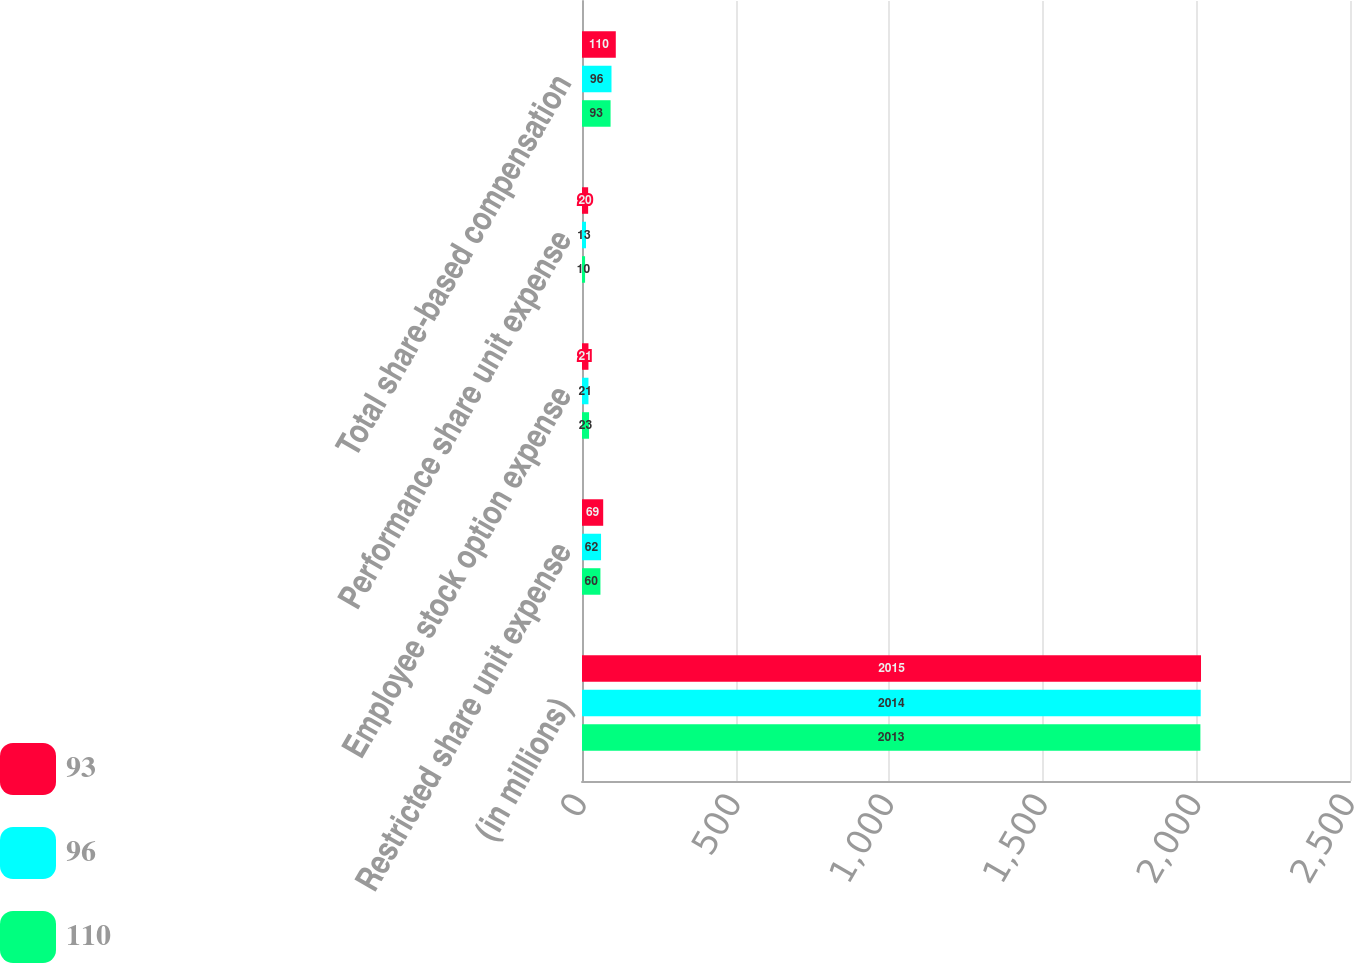Convert chart. <chart><loc_0><loc_0><loc_500><loc_500><stacked_bar_chart><ecel><fcel>(in millions)<fcel>Restricted share unit expense<fcel>Employee stock option expense<fcel>Performance share unit expense<fcel>Total share-based compensation<nl><fcel>93<fcel>2015<fcel>69<fcel>21<fcel>20<fcel>110<nl><fcel>96<fcel>2014<fcel>62<fcel>21<fcel>13<fcel>96<nl><fcel>110<fcel>2013<fcel>60<fcel>23<fcel>10<fcel>93<nl></chart> 